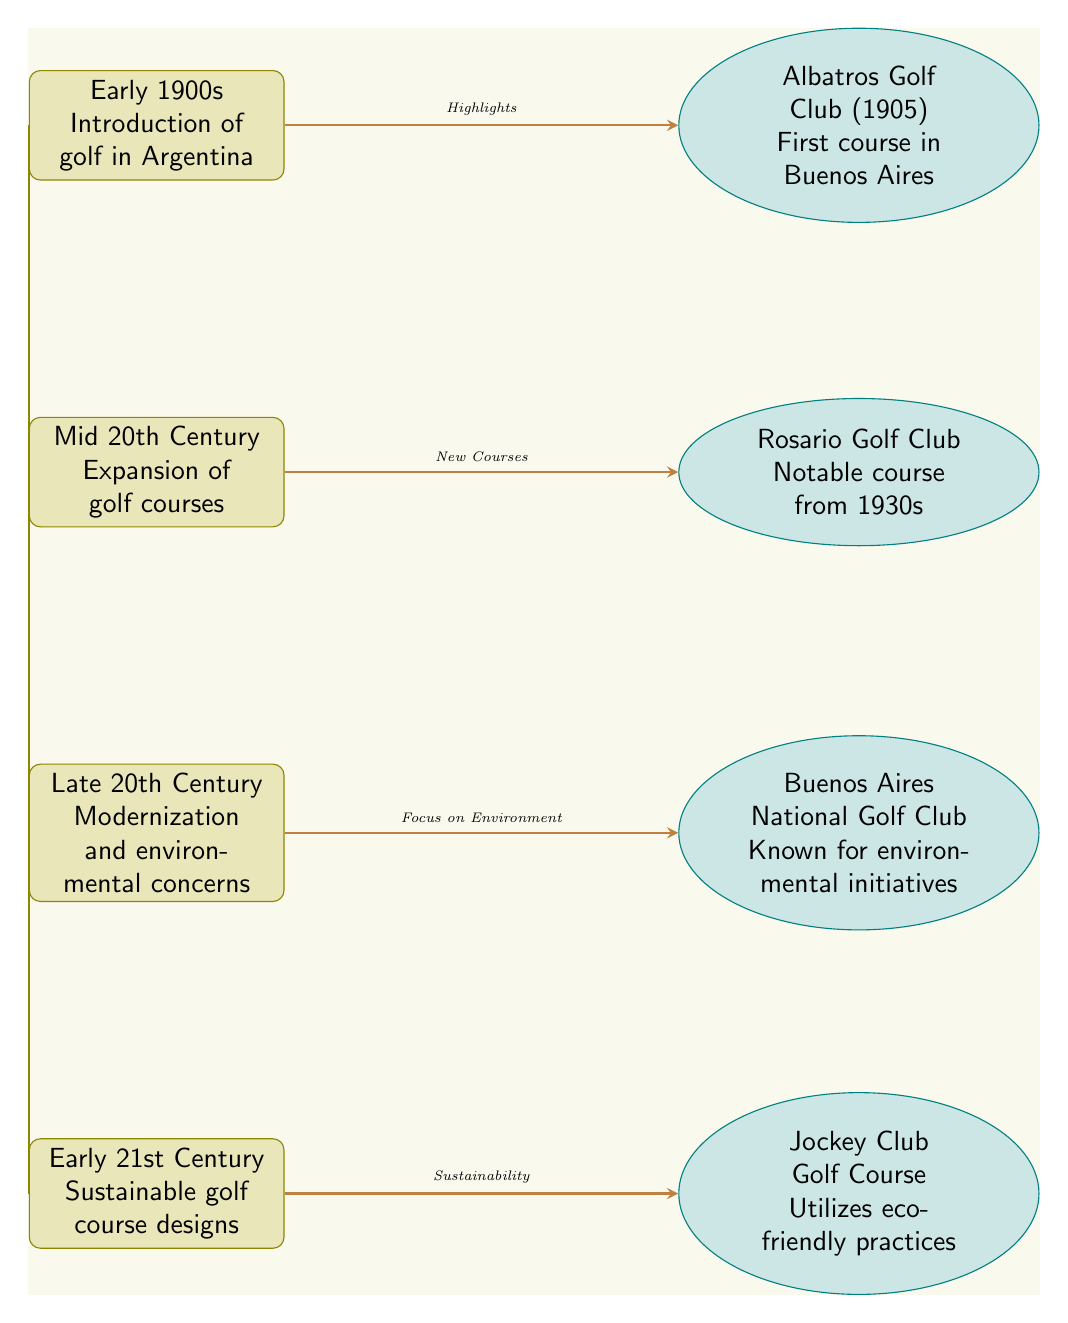What event marks the introduction of golf in Argentina? The diagram indicates that the early 1900s is the time period when golf was first introduced in Argentina.
Answer: Introduction of golf in Argentina Which golf course was established first in Buenos Aires? According to the diagram, Albatros Golf Club, established in 1905, is the first golf course listed in Buenos Aires.
Answer: Albatros Golf Club (1905) How many notable golf courses are highlighted in the diagram? The diagram shows four notable golf courses: Albatros Golf Club, Rosario Golf Club, Buenos Aires National Golf Club, and Jockey Club Golf Course, indicating a total of four.
Answer: 4 What change occurred in the late 20th century regarding golf courses? The diagram states that during the late 20th century, there was a focus on environmental concerns related to golf courses.
Answer: Focus on Environment Which golf course is known for its environmental initiatives? The diagram notes that Buenos Aires National Golf Club is recognized for its environmental initiatives among the listed courses.
Answer: Buenos Aires National Golf Club What type of golf course designs emerged in the early 21st century? The diagram indicates that in the early 21st century, sustainable golf course designs began to emerge.
Answer: Sustainable golf course designs How does the introduction of golf in the early 1900s relate to the expansion of golf courses? The diagram shows a chronological progression where the introduction of golf in the early 1900s is followed by the expansion of golf courses in the mid-20th century, suggesting a direct relationship between the two events.
Answer: Expansion of golf courses What environmental practices does the Jockey Club Golf Course utilize? The diagram explicitly states that the Jockey Club Golf Course utilizes eco-friendly practices, distinguishing it from others mentioned.
Answer: Eco-friendly practices 